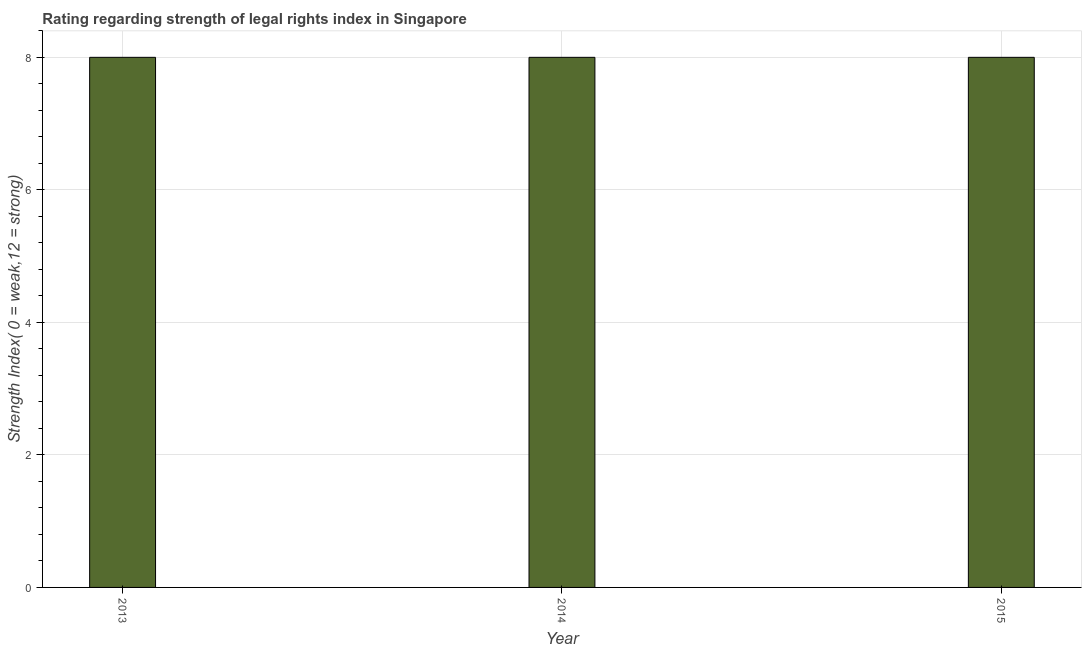Does the graph contain grids?
Give a very brief answer. Yes. What is the title of the graph?
Ensure brevity in your answer.  Rating regarding strength of legal rights index in Singapore. What is the label or title of the Y-axis?
Offer a very short reply. Strength Index( 0 = weak,12 = strong). What is the strength of legal rights index in 2014?
Ensure brevity in your answer.  8. Across all years, what is the maximum strength of legal rights index?
Give a very brief answer. 8. What is the ratio of the strength of legal rights index in 2013 to that in 2015?
Your answer should be very brief. 1. Is the difference between the strength of legal rights index in 2014 and 2015 greater than the difference between any two years?
Make the answer very short. Yes. What is the difference between the highest and the second highest strength of legal rights index?
Make the answer very short. 0. In how many years, is the strength of legal rights index greater than the average strength of legal rights index taken over all years?
Your answer should be very brief. 0. How many bars are there?
Your answer should be very brief. 3. Are all the bars in the graph horizontal?
Your answer should be very brief. No. What is the Strength Index( 0 = weak,12 = strong) in 2013?
Your answer should be compact. 8. What is the difference between the Strength Index( 0 = weak,12 = strong) in 2014 and 2015?
Your response must be concise. 0. 